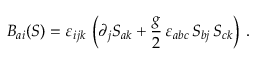<formula> <loc_0><loc_0><loc_500><loc_500>B _ { a i } ( S ) = \varepsilon _ { i j k } \, \left ( \partial _ { j } S _ { a k } + \frac { g } { 2 } \, \varepsilon _ { a b c } \, S _ { b j } \, S _ { c k } \right ) \, .</formula> 